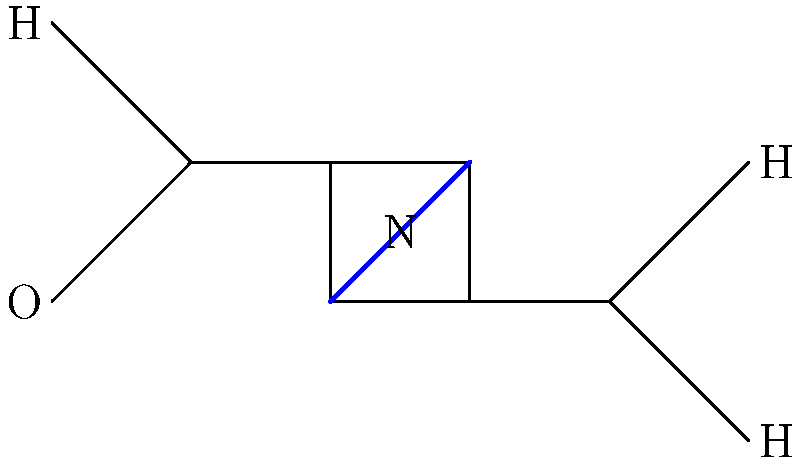Identify the functional groups present in the chemical structure of indigo, a natural dye commonly used in vintage textiles, and explain how these groups contribute to its dyeing properties. To answer this question, let's analyze the chemical structure of indigo step-by-step:

1. Observe the molecule structure:
   - The structure shows a symmetrical molecule with two main ring systems.

2. Identify the functional groups:
   a) Carbonyl group (C=O):
      - Located at the center of each ring.
      - Contributes to the molecule's polarity and ability to form hydrogen bonds.

   b) Amine group (N-H):
      - Present on each ring.
      - Provides sites for hydrogen bonding with fabric fibers.

   c) Double bonds:
      - Present within the rings and connecting them.
      - Contribute to the conjugated system, which is responsible for the dye's color.

3. Understand the dyeing properties:
   - The carbonyl and amine groups allow indigo to form hydrogen bonds with fabric fibers, particularly cellulose in cotton.
   - The conjugated system of double bonds absorbs light in the visible spectrum, giving indigo its characteristic blue color.
   - Indigo is insoluble in water in its oxidized form but becomes soluble when reduced, allowing it to penetrate fabric fibers.

4. Dyeing process:
   - Indigo is reduced to its soluble "leuco" form, which is colorless.
   - The fabric is immersed in the dye bath, and the leuco-indigo penetrates the fibers.
   - Upon exposure to air, the indigo oxidizes back to its insoluble blue form within the fabric, creating a stable dye.

The combination of these functional groups and their properties make indigo an effective and long-lasting natural dye for textiles.
Answer: Carbonyl (C=O), amine (N-H), and conjugated double bonds 